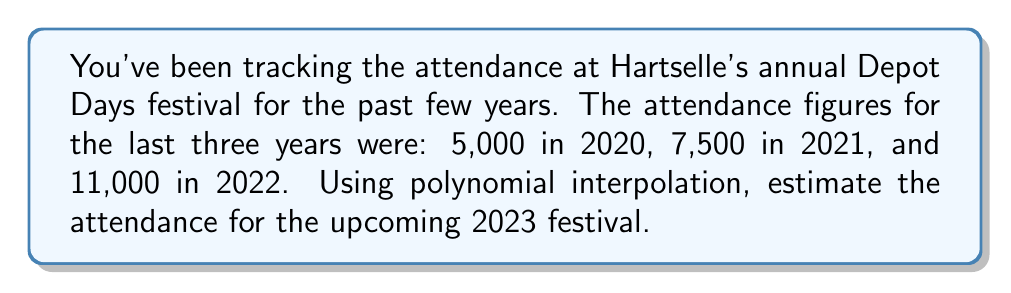Can you solve this math problem? To estimate the attendance for 2023 using polynomial interpolation, we'll follow these steps:

1) Let's assign x-values to each year, with 2020 as x = 0, 2021 as x = 1, and 2022 as x = 2. We want to find the attendance for 2023, which would be x = 3.

2) We'll use the Lagrange interpolation formula to find a quadratic polynomial that passes through these three points:

   $$(0, 5000), (1, 7500), (2, 11000)$$

3) The Lagrange interpolation polynomial is:

   $$P(x) = y_0L_0(x) + y_1L_1(x) + y_2L_2(x)$$

   where:
   $$L_0(x) = \frac{(x-1)(x-2)}{(0-1)(0-2)}$$
   $$L_1(x) = \frac{(x-0)(x-2)}{(1-0)(1-2)}$$
   $$L_2(x) = \frac{(x-0)(x-1)}{(2-0)(2-1)}$$

4) Substituting the y-values:

   $$P(x) = 5000L_0(x) + 7500L_1(x) + 11000L_2(x)$$

5) Simplifying:

   $$P(x) = 5000\frac{x^2-3x+2}{2} - 7500(x^2-2x) + 11000\frac{x^2-x}{2}$$

6) Combining like terms:

   $$P(x) = 1000x^2 + 500x + 5000$$

7) To estimate the attendance for 2023, we evaluate P(3):

   $$P(3) = 1000(3^2) + 500(3) + 5000 = 9000 + 1500 + 5000 = 15500$$

Therefore, the estimated attendance for the 2023 Depot Days festival is 15,500 people.
Answer: 15,500 people 